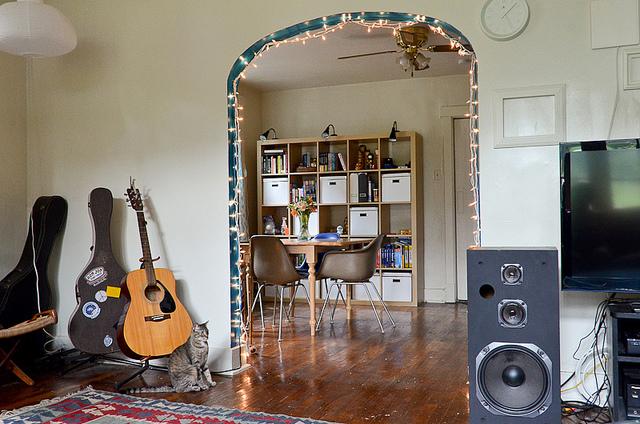How many guitar cases are there?
Give a very brief answer. 2. What room is this?
Write a very short answer. Living room. Is the cat playing the guitar?
Give a very brief answer. No. How many objects on the shelf?
Write a very short answer. Many. How many chairs are seen?
Answer briefly. 2. How much music will be made with the guitar?
Be succinct. Lot. 